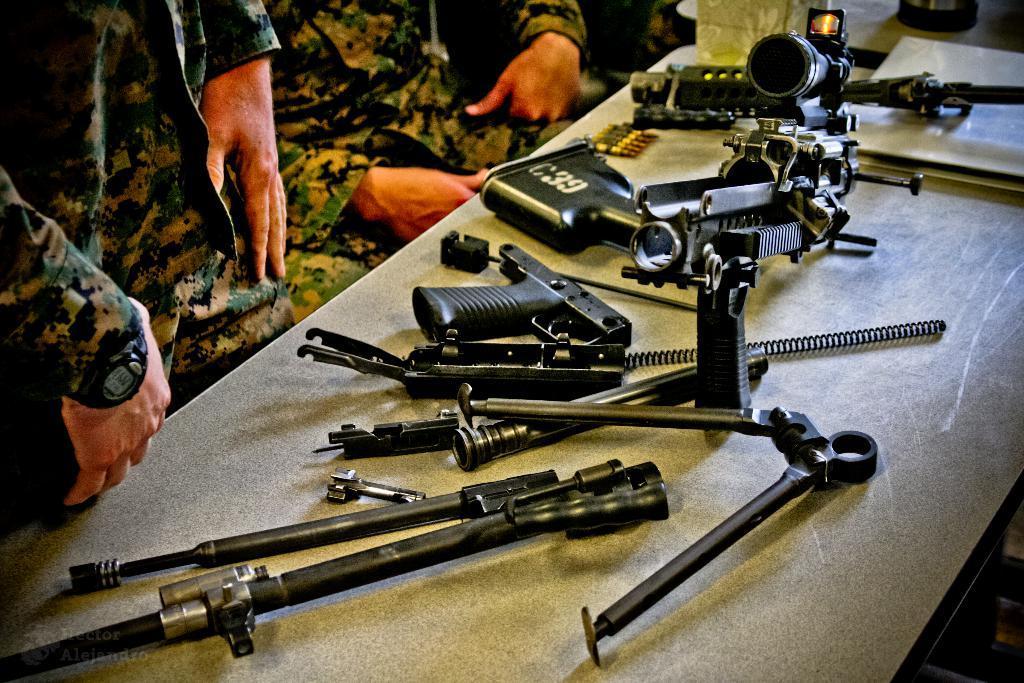In one or two sentences, can you explain what this image depicts? In the picture we can see a desk on it, we can see some guns and some parts of it and some bullets and near to the table we can see some army people are sitting with a uniform. 